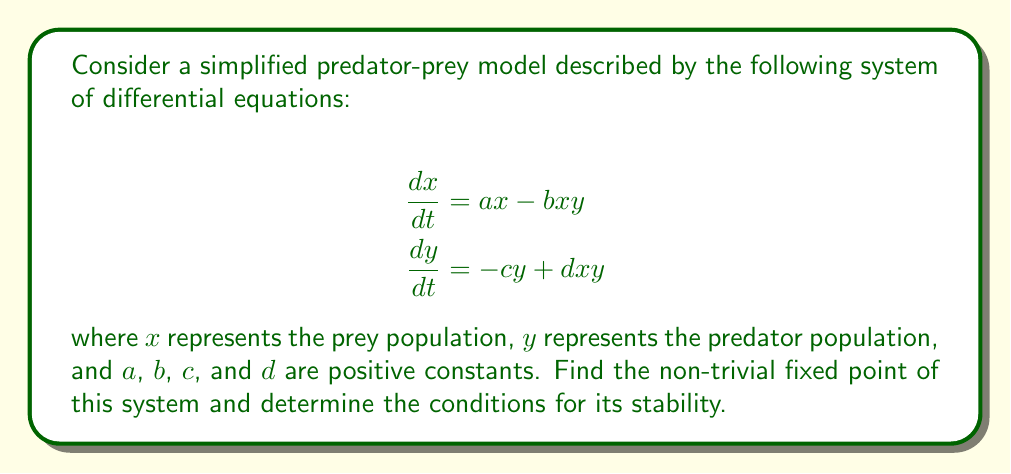Teach me how to tackle this problem. To find the fixed points and analyze their stability, we'll follow these steps:

1) Find the fixed points by setting both equations to zero:
   $$\begin{align}
   ax - bxy &= 0 \\
   -cy + dxy &= 0
   \end{align}$$

2) Solve for the non-trivial fixed point:
   From the first equation: $x(a - by) = 0$
   From the second equation: $y(-c + dx) = 0$
   
   The non-trivial solution occurs when $y = \frac{a}{b}$ and $x = \frac{c}{d}$

3) To determine stability, we need to calculate the Jacobian matrix at the fixed point:
   $$J = \begin{bmatrix}
   \frac{\partial}{\partial x}(ax - bxy) & \frac{\partial}{\partial y}(ax - bxy) \\
   \frac{\partial}{\partial x}(-cy + dxy) & \frac{\partial}{\partial y}(-cy + dxy)
   \end{bmatrix}$$

   $$J = \begin{bmatrix}
   a - by & -bx \\
   dy & -c + dx
   \end{bmatrix}$$

4) Evaluate the Jacobian at the fixed point $(\frac{c}{d}, \frac{a}{b})$:
   $$J_{(\frac{c}{d}, \frac{a}{b})} = \begin{bmatrix}
   0 & -\frac{bc}{d} \\
   \frac{ad}{b} & 0
   \end{bmatrix}$$

5) For stability, we need the eigenvalues of this matrix to have negative real parts. The characteristic equation is:
   $$\lambda^2 + ac = 0$$

6) The eigenvalues are:
   $$\lambda = \pm i\sqrt{ac}$$

7) Since the real parts of these eigenvalues are zero, the fixed point is neutrally stable. This means that solutions near this fixed point will oscillate around it, neither converging to it nor diverging from it.

This behavior is consistent with the classic Lotka-Volterra model, where predator and prey populations oscillate in cycles around a fixed point, demonstrating the evolutionary balance between species in an ecosystem.
Answer: Non-trivial fixed point: $(\frac{c}{d}, \frac{a}{b})$; Neutrally stable 